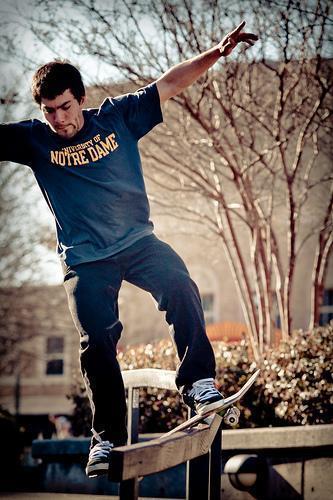How many people are pictured?
Give a very brief answer. 1. 